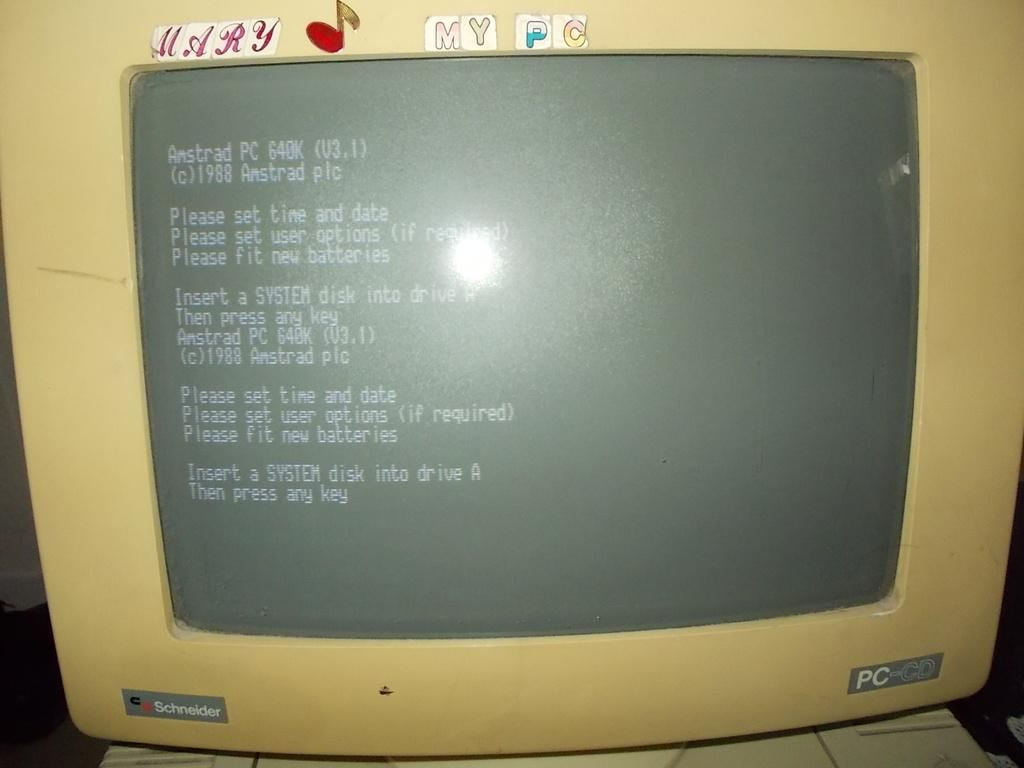<image>
Render a clear and concise summary of the photo. An old Schneider PC with kids stickers added at the top. 